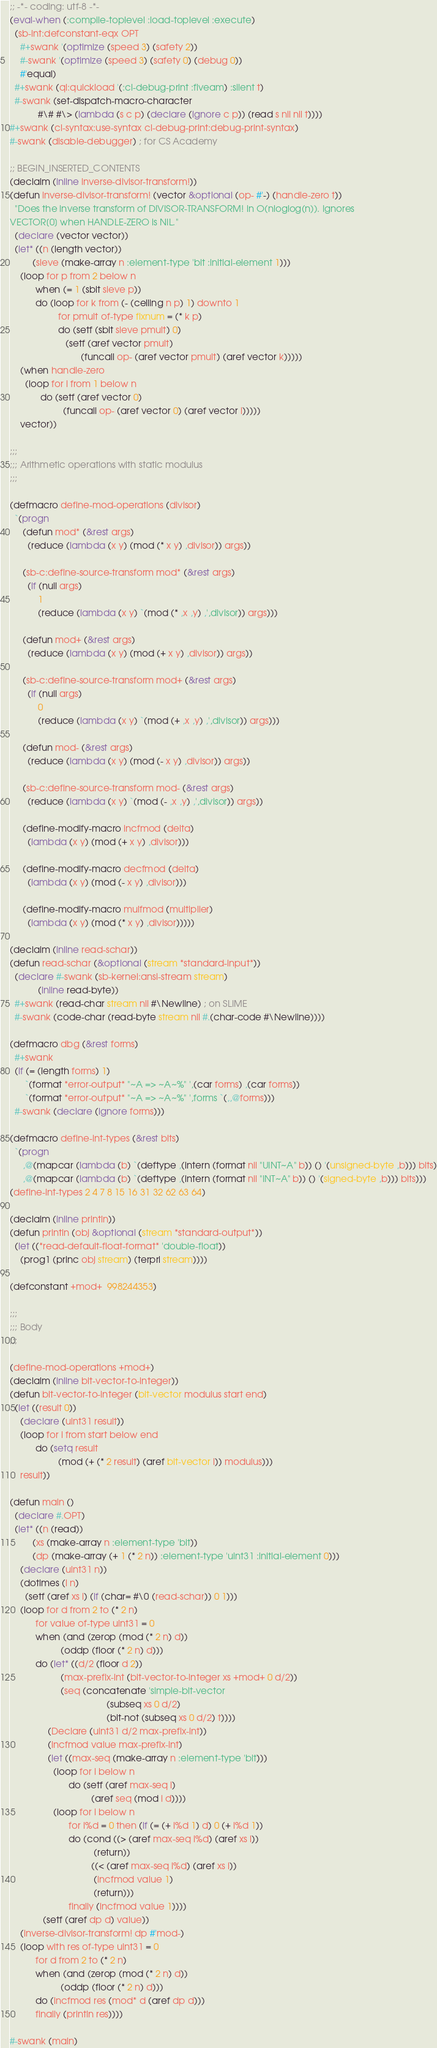Convert code to text. <code><loc_0><loc_0><loc_500><loc_500><_Lisp_>;; -*- coding: utf-8 -*-
(eval-when (:compile-toplevel :load-toplevel :execute)
  (sb-int:defconstant-eqx OPT
    #+swank '(optimize (speed 3) (safety 2))
    #-swank '(optimize (speed 3) (safety 0) (debug 0))
    #'equal)
  #+swank (ql:quickload '(:cl-debug-print :fiveam) :silent t)
  #-swank (set-dispatch-macro-character
           #\# #\> (lambda (s c p) (declare (ignore c p)) (read s nil nil t))))
#+swank (cl-syntax:use-syntax cl-debug-print:debug-print-syntax)
#-swank (disable-debugger) ; for CS Academy

;; BEGIN_INSERTED_CONTENTS
(declaim (inline inverse-divisor-transform!))
(defun inverse-divisor-transform! (vector &optional (op- #'-) (handle-zero t))
  "Does the inverse transform of DIVISOR-TRANSFORM! in O(nloglog(n)). Ignores
VECTOR[0] when HANDLE-ZERO is NIL."
  (declare (vector vector))
  (let* ((n (length vector))
         (sieve (make-array n :element-type 'bit :initial-element 1)))
    (loop for p from 2 below n
          when (= 1 (sbit sieve p))
          do (loop for k from (- (ceiling n p) 1) downto 1
                   for pmult of-type fixnum = (* k p)
                   do (setf (sbit sieve pmult) 0)
                      (setf (aref vector pmult)
                            (funcall op- (aref vector pmult) (aref vector k)))))
    (when handle-zero
      (loop for i from 1 below n
            do (setf (aref vector 0)
                     (funcall op- (aref vector 0) (aref vector i)))))
    vector))

;;;
;;; Arithmetic operations with static modulus
;;;

(defmacro define-mod-operations (divisor)
  `(progn
     (defun mod* (&rest args)
       (reduce (lambda (x y) (mod (* x y) ,divisor)) args))

     (sb-c:define-source-transform mod* (&rest args)
       (if (null args)
           1
           (reduce (lambda (x y) `(mod (* ,x ,y) ,',divisor)) args)))

     (defun mod+ (&rest args)
       (reduce (lambda (x y) (mod (+ x y) ,divisor)) args))

     (sb-c:define-source-transform mod+ (&rest args)
       (if (null args)
           0
           (reduce (lambda (x y) `(mod (+ ,x ,y) ,',divisor)) args)))

     (defun mod- (&rest args)
       (reduce (lambda (x y) (mod (- x y) ,divisor)) args))

     (sb-c:define-source-transform mod- (&rest args)
       (reduce (lambda (x y) `(mod (- ,x ,y) ,',divisor)) args))

     (define-modify-macro incfmod (delta)
       (lambda (x y) (mod (+ x y) ,divisor)))

     (define-modify-macro decfmod (delta)
       (lambda (x y) (mod (- x y) ,divisor)))

     (define-modify-macro mulfmod (multiplier)
       (lambda (x y) (mod (* x y) ,divisor)))))

(declaim (inline read-schar))
(defun read-schar (&optional (stream *standard-input*))
  (declare #-swank (sb-kernel:ansi-stream stream)
           (inline read-byte))
  #+swank (read-char stream nil #\Newline) ; on SLIME
  #-swank (code-char (read-byte stream nil #.(char-code #\Newline))))

(defmacro dbg (&rest forms)
  #+swank
  (if (= (length forms) 1)
      `(format *error-output* "~A => ~A~%" ',(car forms) ,(car forms))
      `(format *error-output* "~A => ~A~%" ',forms `(,,@forms)))
  #-swank (declare (ignore forms)))

(defmacro define-int-types (&rest bits)
  `(progn
     ,@(mapcar (lambda (b) `(deftype ,(intern (format nil "UINT~A" b)) () '(unsigned-byte ,b))) bits)
     ,@(mapcar (lambda (b) `(deftype ,(intern (format nil "INT~A" b)) () '(signed-byte ,b))) bits)))
(define-int-types 2 4 7 8 15 16 31 32 62 63 64)

(declaim (inline println))
(defun println (obj &optional (stream *standard-output*))
  (let ((*read-default-float-format* 'double-float))
    (prog1 (princ obj stream) (terpri stream))))

(defconstant +mod+  998244353)

;;;
;;; Body
;;;

(define-mod-operations +mod+)
(declaim (inline bit-vector-to-integer))
(defun bit-vector-to-integer (bit-vector modulus start end)
  (let ((result 0))
    (declare (uint31 result))
    (loop for i from start below end
          do (setq result
                   (mod (+ (* 2 result) (aref bit-vector i)) modulus)))
    result))

(defun main ()
  (declare #.OPT)
  (let* ((n (read))
         (xs (make-array n :element-type 'bit))
         (dp (make-array (+ 1 (* 2 n)) :element-type 'uint31 :initial-element 0)))
    (declare (uint31 n))
    (dotimes (i n)
      (setf (aref xs i) (if (char= #\0 (read-schar)) 0 1)))
    (loop for d from 2 to (* 2 n)
          for value of-type uint31 = 0
          when (and (zerop (mod (* 2 n) d))
                    (oddp (floor (* 2 n) d)))
          do (let* ((d/2 (floor d 2))
                    (max-prefix-int (bit-vector-to-integer xs +mod+ 0 d/2))
                    (seq (concatenate 'simple-bit-vector
                                      (subseq xs 0 d/2)
                                      (bit-not (subseq xs 0 d/2) t))))
               (Declare (uint31 d/2 max-prefix-int))
               (incfmod value max-prefix-int)
               (let ((max-seq (make-array n :element-type 'bit)))
                 (loop for i below n
                       do (setf (aref max-seq i)
                                (aref seq (mod i d))))
                 (loop for i below n
                       for i%d = 0 then (if (= (+ i%d 1) d) 0 (+ i%d 1))
                       do (cond ((> (aref max-seq i%d) (aref xs i))
                                 (return))
                                ((< (aref max-seq i%d) (aref xs i))
                                 (incfmod value 1)
                                 (return)))
                       finally (incfmod value 1))))
             (setf (aref dp d) value))
    (inverse-divisor-transform! dp #'mod-)
    (loop with res of-type uint31 = 0
          for d from 2 to (* 2 n)
          when (and (zerop (mod (* 2 n) d))
                    (oddp (floor (* 2 n) d)))
          do (incfmod res (mod* d (aref dp d)))
          finally (println res))))

#-swank (main)
</code> 